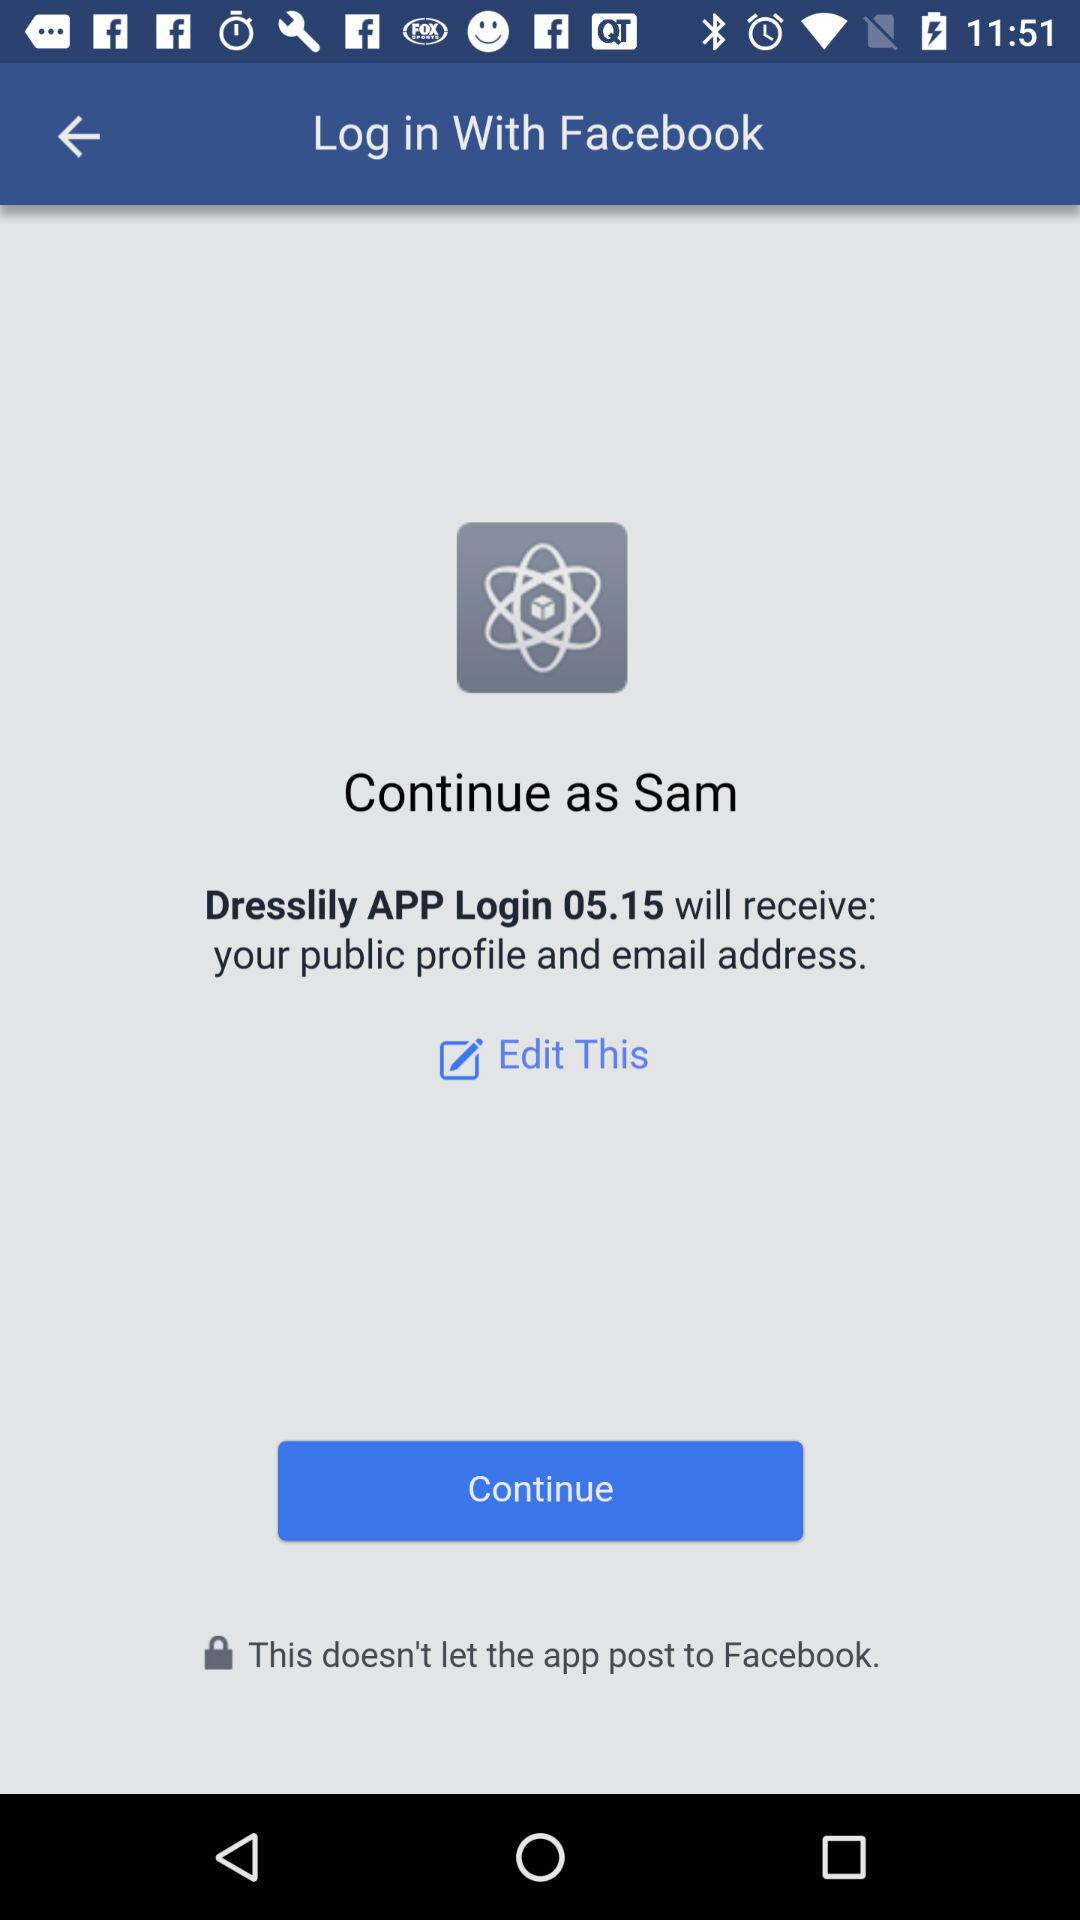What is the login name? The login name is Sam. 